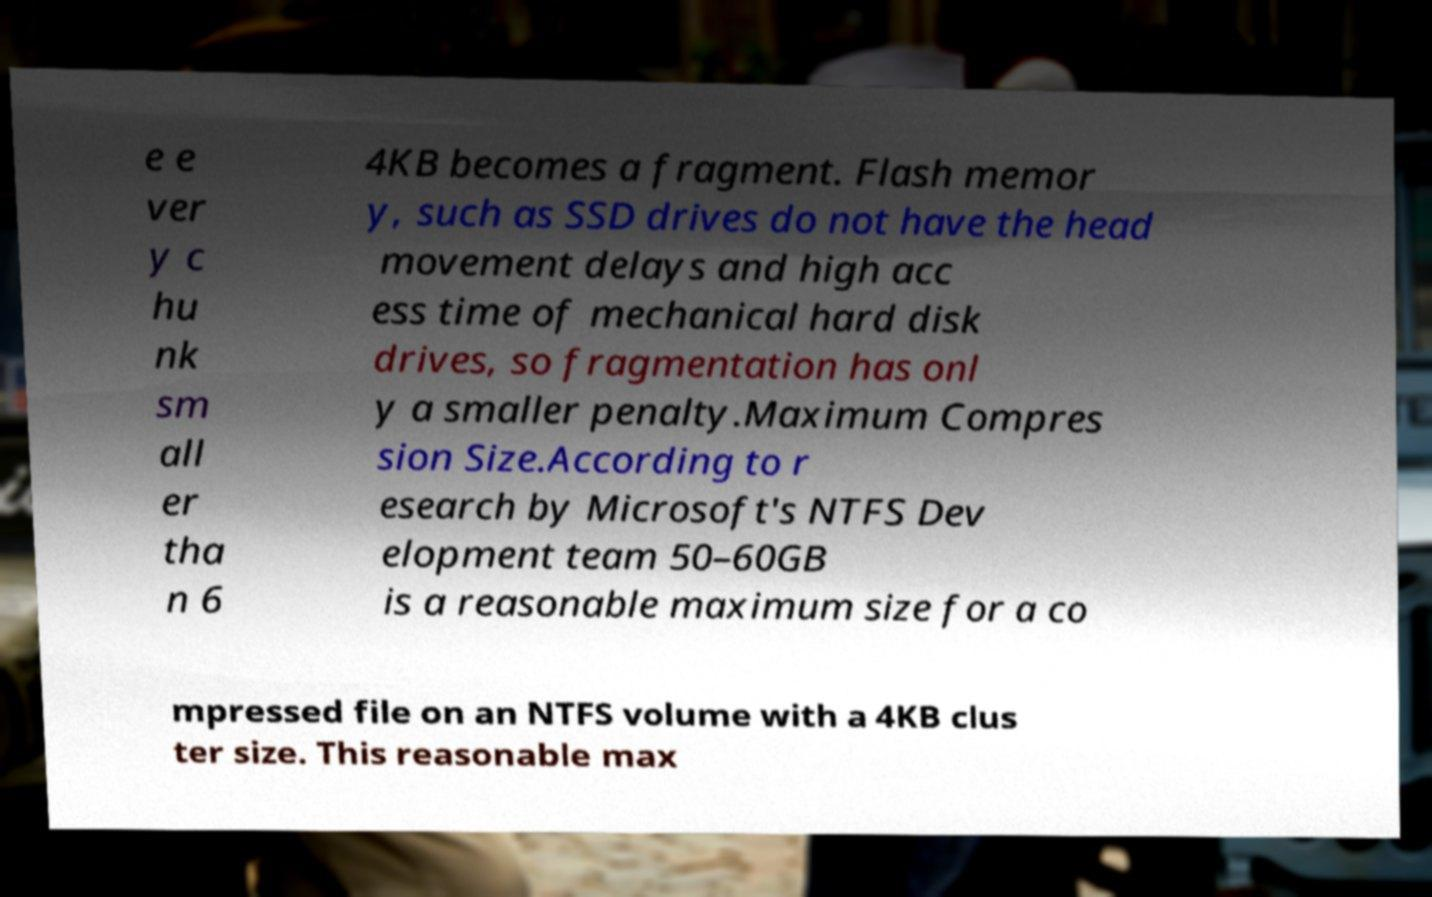Could you assist in decoding the text presented in this image and type it out clearly? e e ver y c hu nk sm all er tha n 6 4KB becomes a fragment. Flash memor y, such as SSD drives do not have the head movement delays and high acc ess time of mechanical hard disk drives, so fragmentation has onl y a smaller penalty.Maximum Compres sion Size.According to r esearch by Microsoft's NTFS Dev elopment team 50–60GB is a reasonable maximum size for a co mpressed file on an NTFS volume with a 4KB clus ter size. This reasonable max 